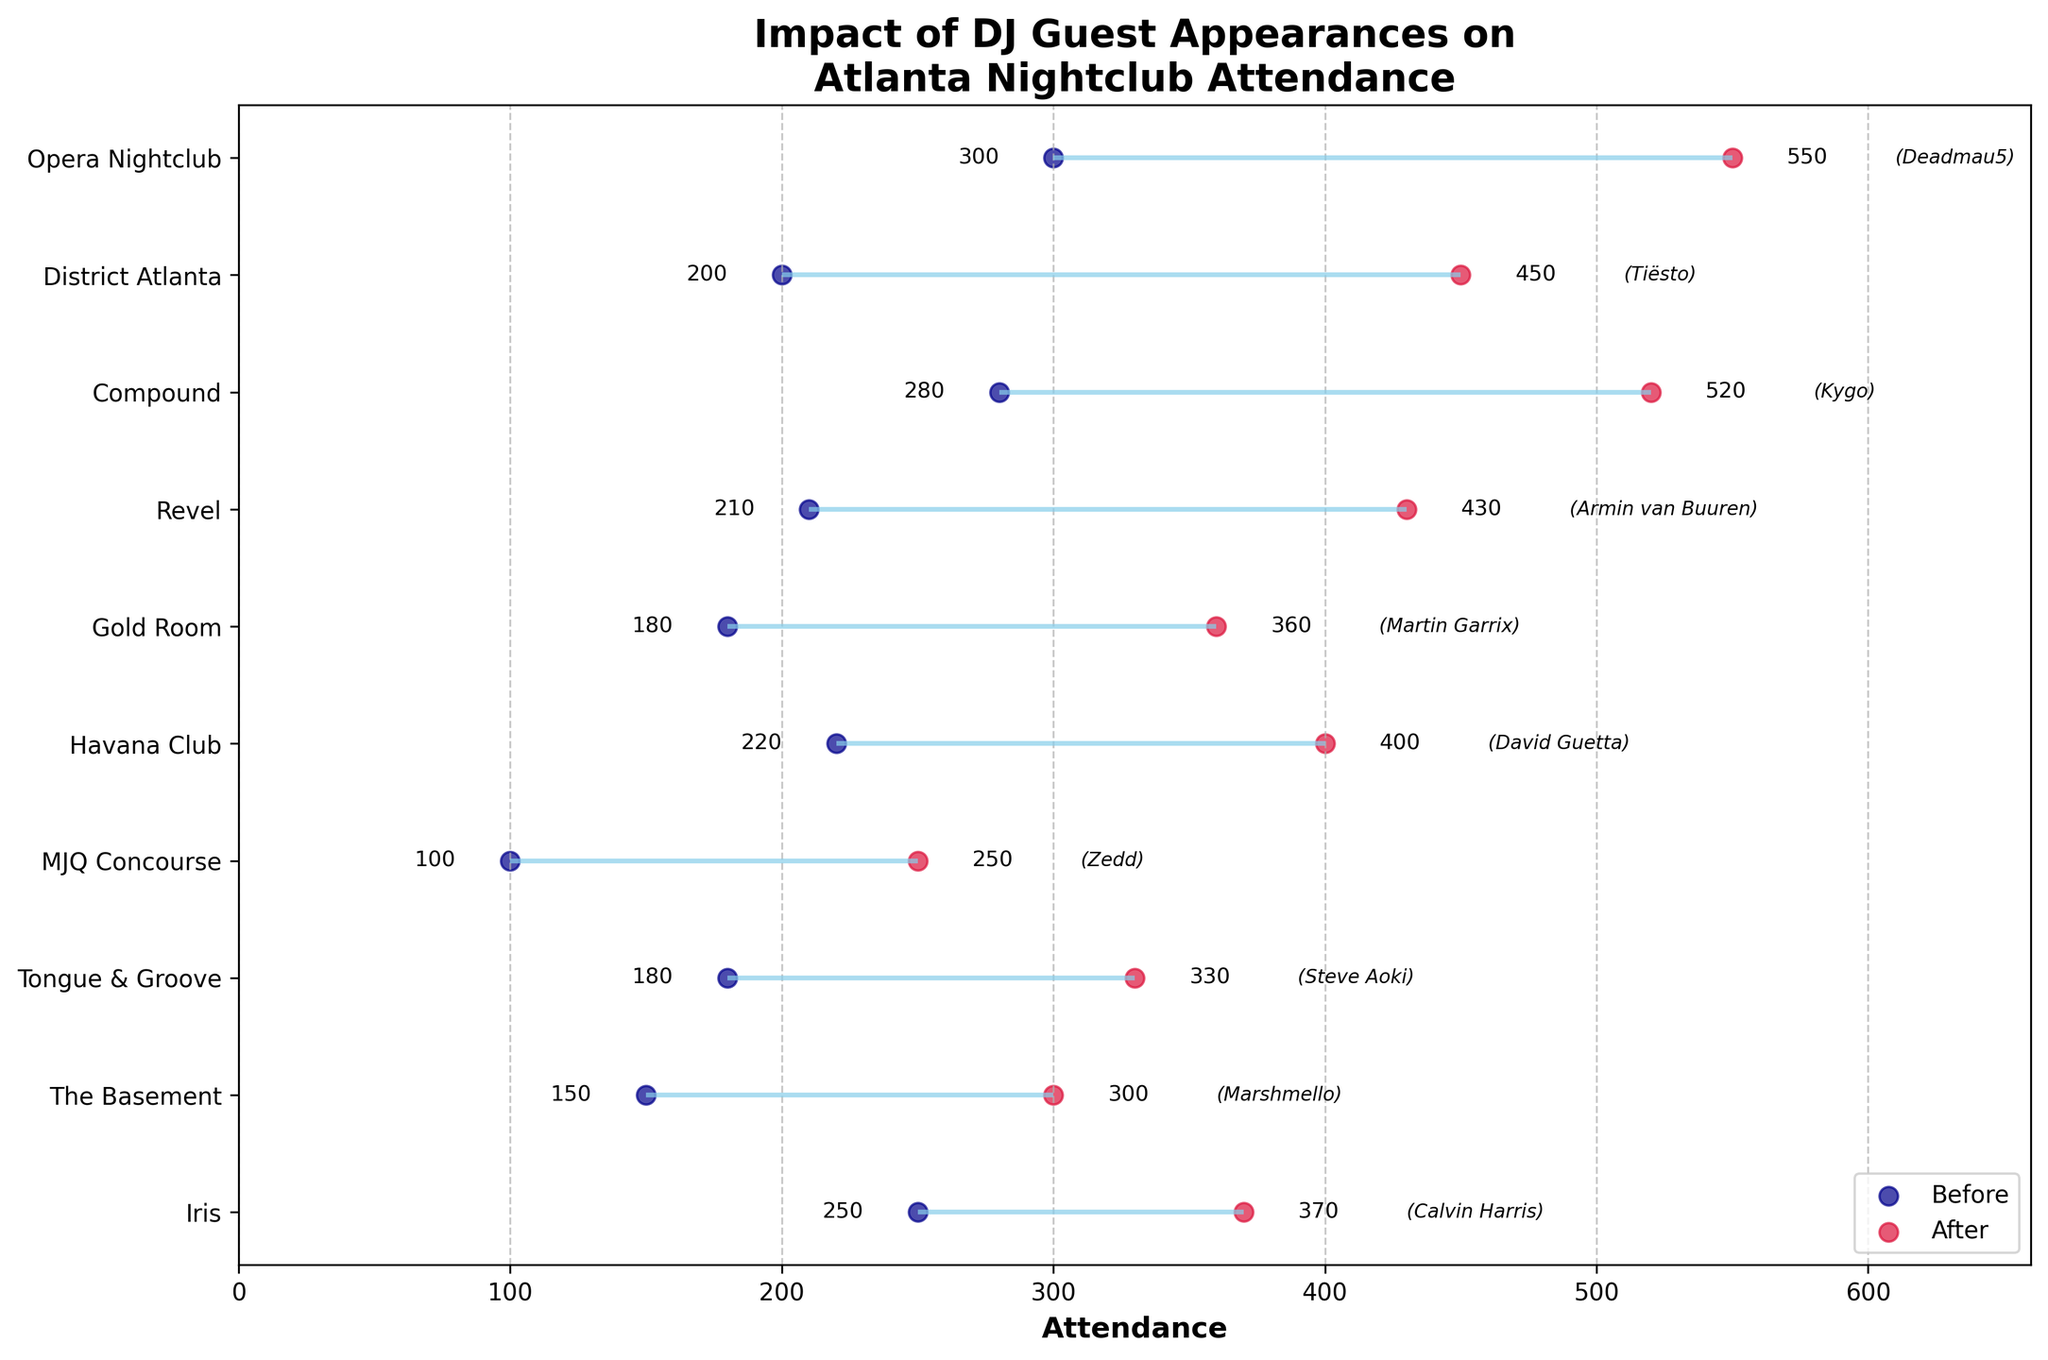What is the title of the plot? The title is displayed at the top of the plot and summarizes its content. In this case, it's "Impact of DJ Guest Appearances on Atlanta Nightclub Attendance."
Answer: Impact of DJ Guest Appearances on Atlanta Nightclub Attendance Which nightclub had the highest attendance after the DJ guest appearance? Look at the red dots that represent attendance after the DJ guest appearances. Identify the nightclub label corresponding to the highest red dot. The highest attendance value post-appearance is for Opera Nightclub.
Answer: Opera Nightclub How many nightclubs showed an increase in attendance after the DJ guest appearance? All the nightclubs displayed show two attendance values: 'Before' (dark blue) and 'After' (red). Since this is a Dumbbell Plot, and every 'After' value is greater than the corresponding 'Before' value, all nightclubs shown have increased attendance. Count all the plot elements; there are 10.
Answer: 10 Which DJ appearance resulted in the smallest increase in attendance? Calculate the difference between 'Attendance_After' and 'Attendance_Before' for each row, shown graphically by the smallest horizontal distance between dark blue and red dots. The smallest difference is seen for Iris.
Answer: Calvin Harris What is the average attendance before the DJ guest appearances? Sum all the 'Attendance_Before' values and divide by the total number of nightclubs. The sum is 150+200+180+100+250+300+220+180+210+280 = 2070. There are 10 nightclubs, so the average is 2070/10 = 207.
Answer: 207 What is the difference in attendance at The Basement after Marshmello's appearance? Locate The Basement on the y-axis and compare the 'Attendance_Before' (150) and 'Attendance_After' (300). Subtract the before value from the after value: 300 - 150 = 150.
Answer: 150 How many DJs caused the attendance to double at their respective nightclubs? For the attendance to double, 'Attendance_After' needs to be at least twice 'Attendance_Before.' Calculate for each nightclub:
- The Basement: 300 ≥ 2*150 (True)
- District Atlanta: 450 ≥ 2*200 (True)
- Tongue & Groove: 330 ≥ 2*180 (False)
- MJQ Concourse: 250 ≥ 2*100 (True)
- Iris: 370 ≥ 2*250 (False)
- Opera Nightclub: 550 ≥ 2*300 (False)
- Havana Club: 400 ≥ 2*220 (False)
- Gold Room: 360 ≥ 2*180 (True)
- Revel: 430 ≥ 2*210 (True)
- Compound: 520 ≥ 2*280 (True)
Count the true cases; there are 6.
Answer: 6 Which nightclub had more than double the attendance after the DJ guest appearance compared to before? Look for nightclubs where 'Attendance_After' is more than double 'Attendance_Before' based on the visual distance between dots. The Basement, District Atlanta, MJQ Concourse, Gold Room, Revel, and Compound have more than double the attendance after appearances.
Answer: The Basement, District Atlanta, MJQ Concourse, Gold Room, Revel, Compound 